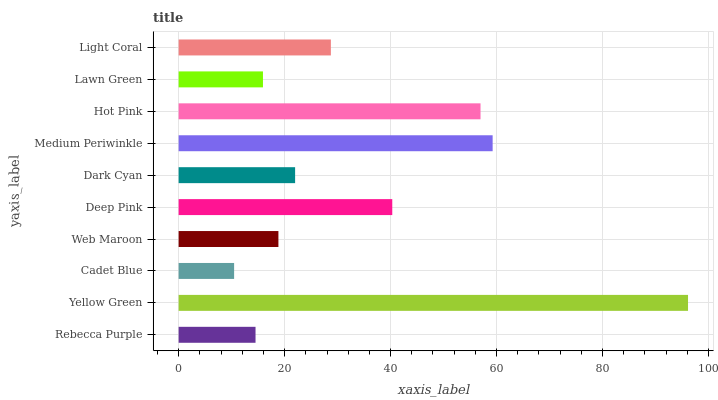Is Cadet Blue the minimum?
Answer yes or no. Yes. Is Yellow Green the maximum?
Answer yes or no. Yes. Is Yellow Green the minimum?
Answer yes or no. No. Is Cadet Blue the maximum?
Answer yes or no. No. Is Yellow Green greater than Cadet Blue?
Answer yes or no. Yes. Is Cadet Blue less than Yellow Green?
Answer yes or no. Yes. Is Cadet Blue greater than Yellow Green?
Answer yes or no. No. Is Yellow Green less than Cadet Blue?
Answer yes or no. No. Is Light Coral the high median?
Answer yes or no. Yes. Is Dark Cyan the low median?
Answer yes or no. Yes. Is Lawn Green the high median?
Answer yes or no. No. Is Cadet Blue the low median?
Answer yes or no. No. 